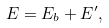Convert formula to latex. <formula><loc_0><loc_0><loc_500><loc_500>E = E _ { b } + E ^ { \prime } ,</formula> 